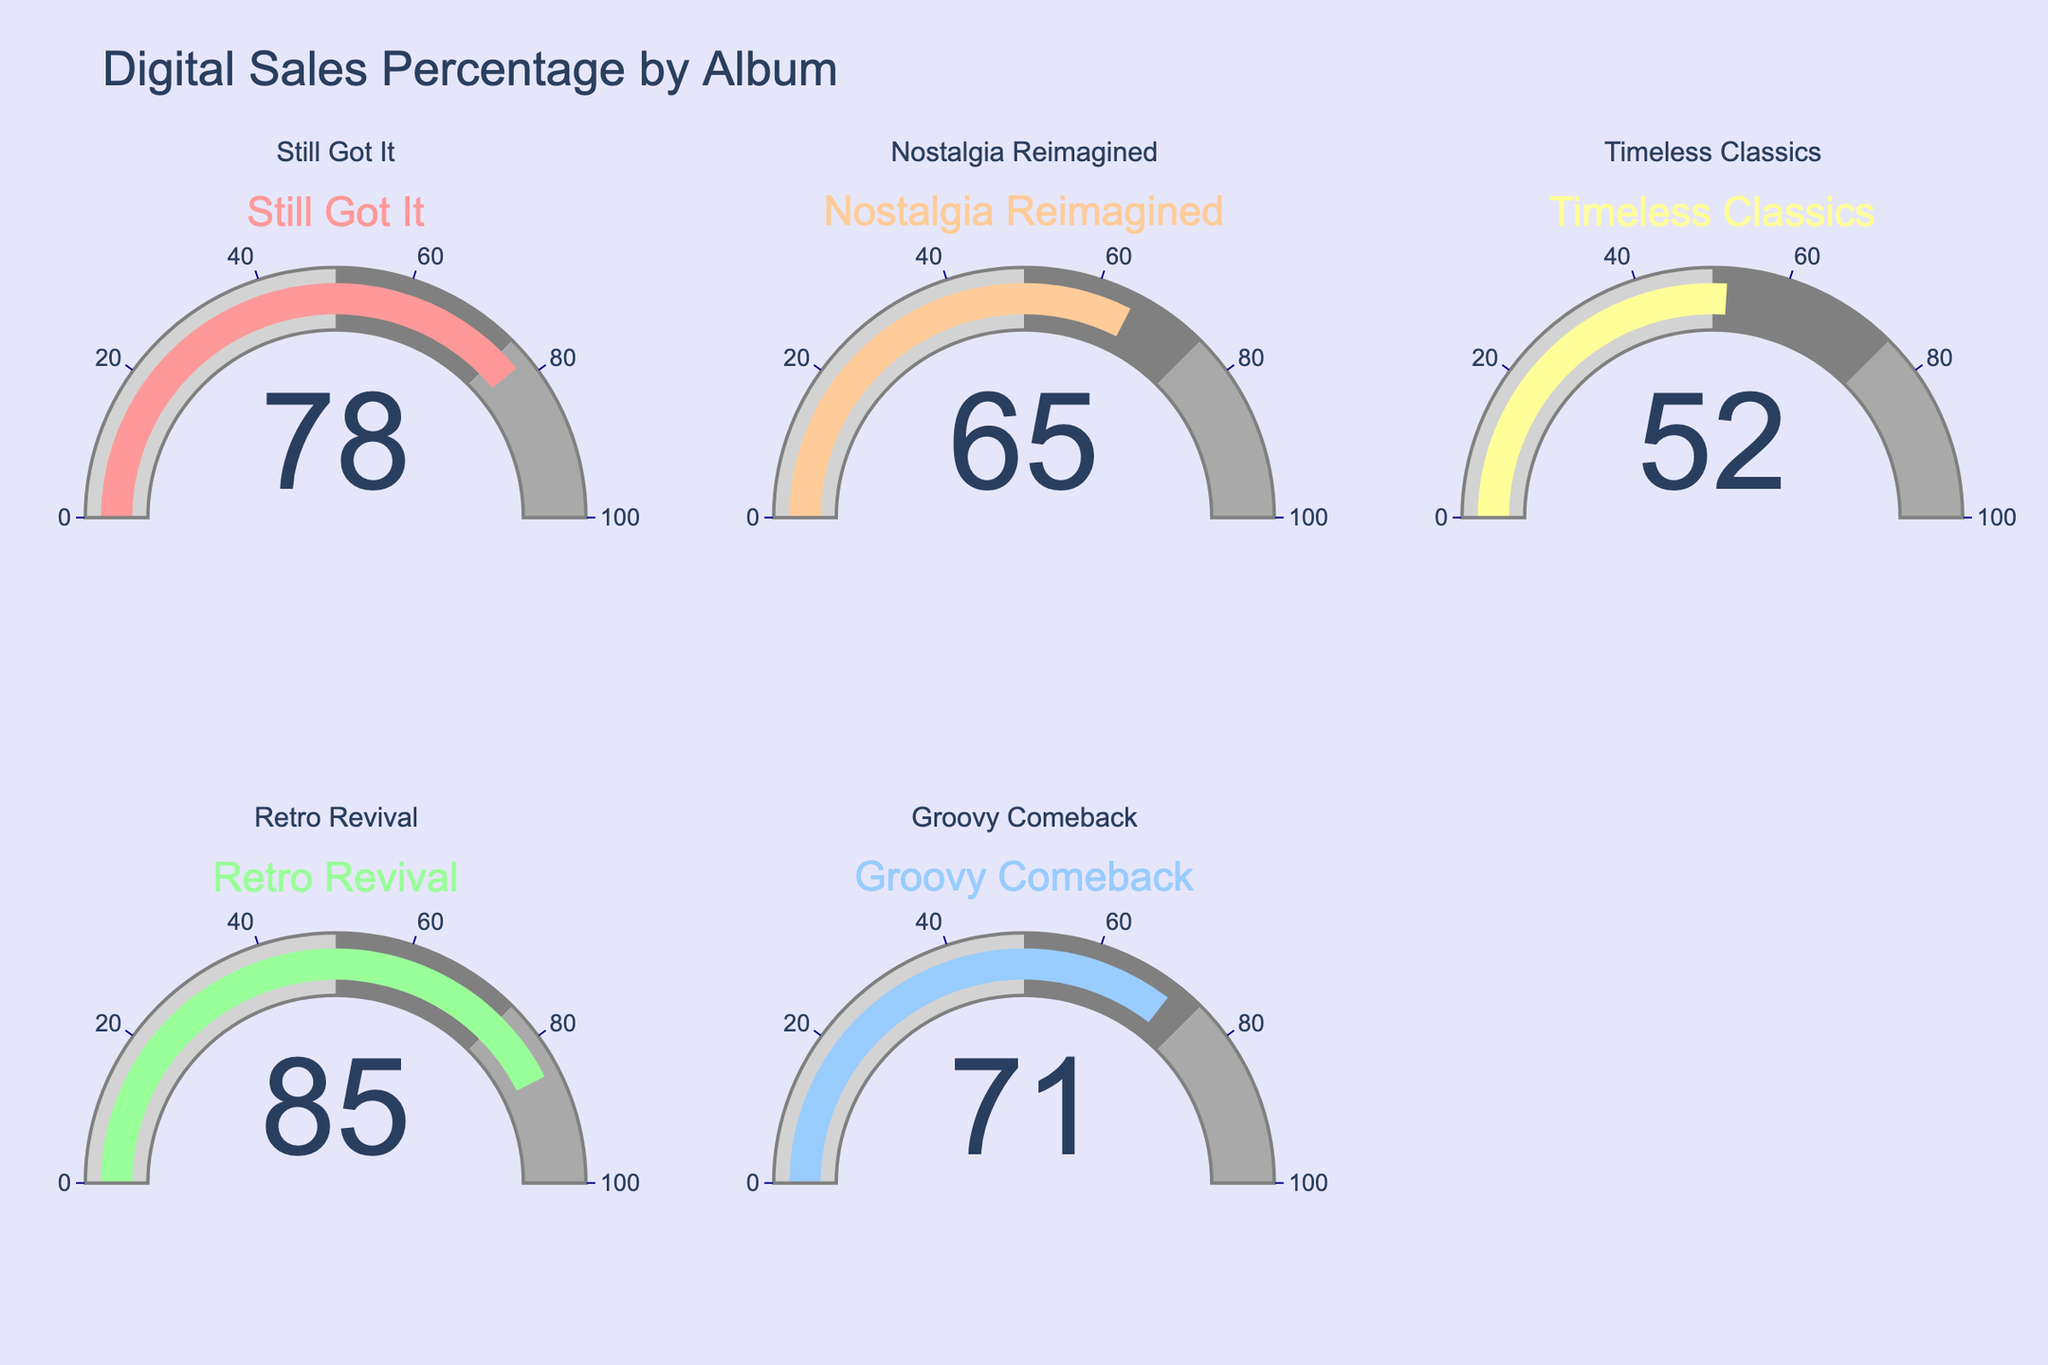What's the title of the figure? The figure title is usually placed at the top and clearly states what the figure is about. In this case, the title is "Digital Sales Percentage by Album".
Answer: Digital Sales Percentage by Album How many albums are displayed in the figure? The figure shows one gauge per album with five gauges present, each representing a different album.
Answer: 5 What percentage of digital sales does the album "Retro Revival" have? The gauge for "Retro Revival" clearly shows a numeric value that represents the digital sales percentage.
Answer: 85% Which album has the lowest percentage of digital sales? By examining all the gauges, the album "Timeless Classics" has the lowest gauge value.
Answer: Timeless Classics How does the sales percentage of "Nostalgia Reimagined" compare to "Groovy Comeback"? Comparing the gauge values for both albums, "Nostalgia Reimagined" (65%) is 6 percentage points lower than "Groovy Comeback" (71%).
Answer: 6% What's the average digital sales percentage across all albums? Sum the percentages (78 + 65 + 52 + 85 + 71) = 351, then divide by the number of albums (5), giving 351/5 = 70.2%.
Answer: 70.2% Is any album's digital sales percentage above 80%? From the given gauges, "Retro Revival" has 85%, which is above 80%.
Answer: Yes, "Retro Revival" What is the range of digital sales percentages across the albums? The minimum percentage is 52% ("Timeless Classics") and the maximum is 85% ("Retro Revival"), giving a range of 85% - 52% = 33%.
Answer: 33% What color is the gauge for "Still Got It"? The gauge for "Still Got It" is colored using the first color in the custom color scale, which is a shade of red (#FF9999).
Answer: Red Which album has a gauge value closest to the overall average digital sales percentage? Calculate the overall average (70.2%) and find the gauge value closest to this average. The gauges are 78%, 65%, 52%, 85%, and 71%. "Groovy Comeback" at 71% is closest.
Answer: Groovy Comeback 